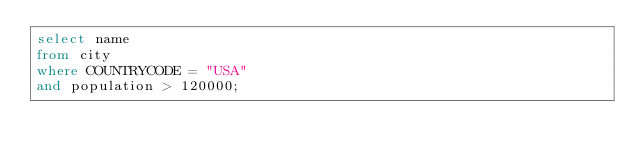<code> <loc_0><loc_0><loc_500><loc_500><_SQL_>select name
from city
where COUNTRYCODE = "USA"
and population > 120000;</code> 